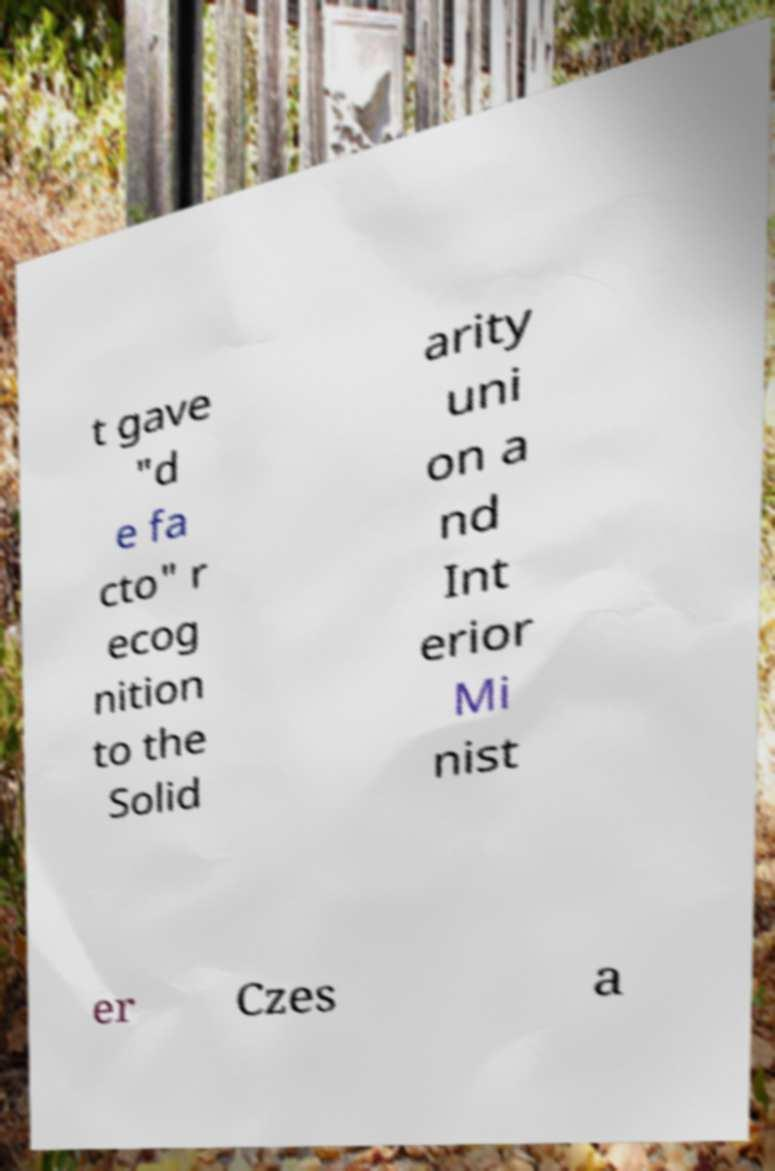Can you accurately transcribe the text from the provided image for me? t gave "d e fa cto" r ecog nition to the Solid arity uni on a nd Int erior Mi nist er Czes a 